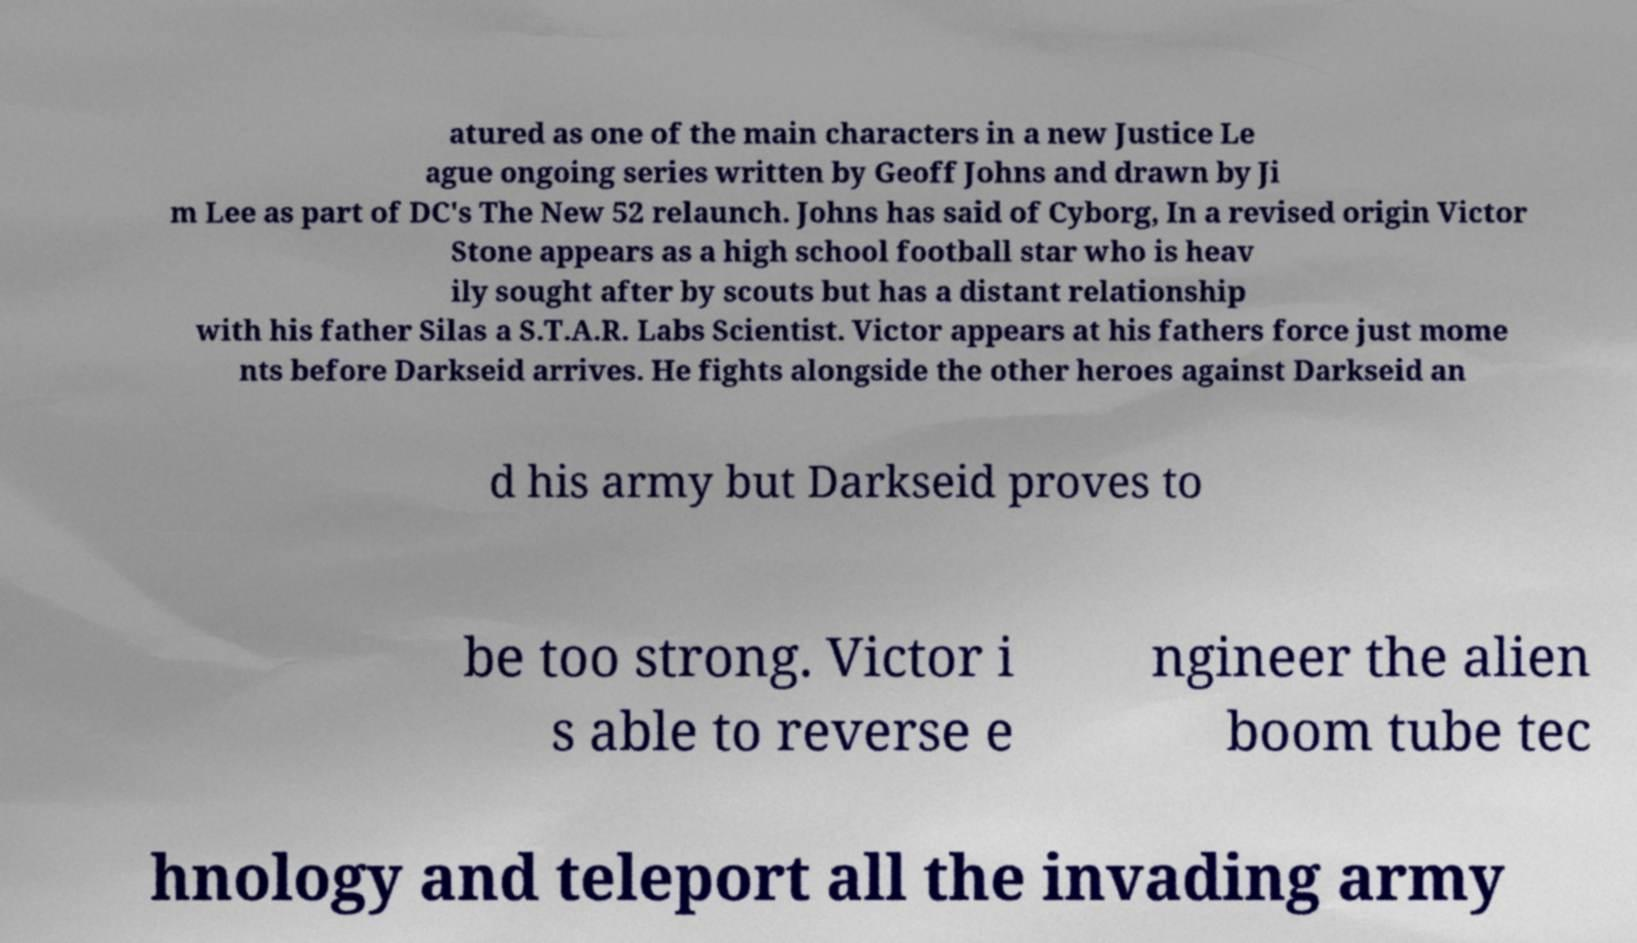Can you accurately transcribe the text from the provided image for me? atured as one of the main characters in a new Justice Le ague ongoing series written by Geoff Johns and drawn by Ji m Lee as part of DC's The New 52 relaunch. Johns has said of Cyborg, In a revised origin Victor Stone appears as a high school football star who is heav ily sought after by scouts but has a distant relationship with his father Silas a S.T.A.R. Labs Scientist. Victor appears at his fathers force just mome nts before Darkseid arrives. He fights alongside the other heroes against Darkseid an d his army but Darkseid proves to be too strong. Victor i s able to reverse e ngineer the alien boom tube tec hnology and teleport all the invading army 